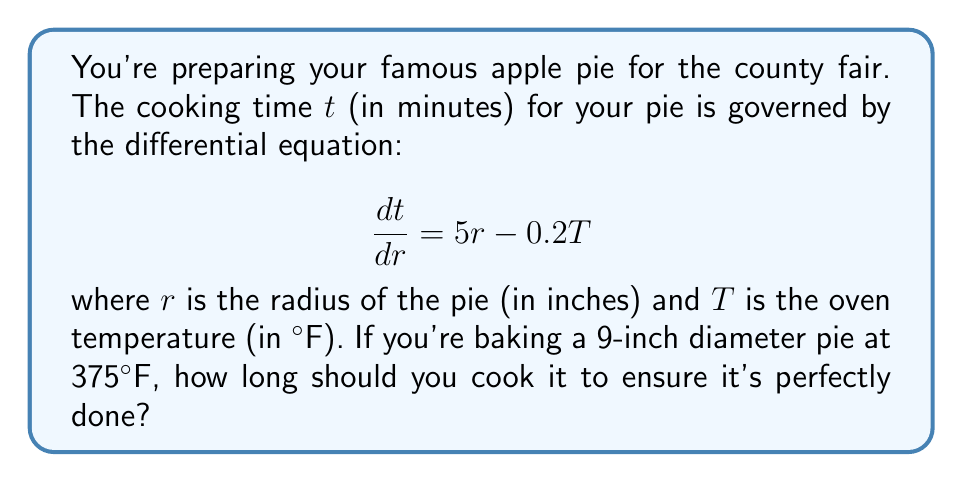Can you solve this math problem? Let's approach this step-by-step:

1) First, we need to solve the differential equation. It's a linear first-order ODE.

2) The general solution to this type of equation is:

   $$t = \int (5r - 0.2T) dr + C$$

3) Integrating with respect to $r$:

   $$t = 2.5r^2 - 0.2Tr + C$$

4) Now, we need to determine the constant $C$. We know that when $r = 0$, $t = 0$ (i.e., no cooking time for a pie with no size). Substituting these values:

   $$0 = 0 - 0 + C$$
   $$C = 0$$

5) So our specific solution is:

   $$t = 2.5r^2 - 0.2Tr$$

6) Now, let's plug in our known values:
   - $r = 4.5$ inches (half the diameter)
   - $T = 375°F$

   $$t = 2.5(4.5^2) - 0.2(375)(4.5)$$
   $$t = 2.5(20.25) - 337.5$$
   $$t = 50.625 - 337.5$$
   $$t = 53.125$$

7) Rounding to the nearest minute:

   $$t \approx 53 \text{ minutes}$$
Answer: 53 minutes 